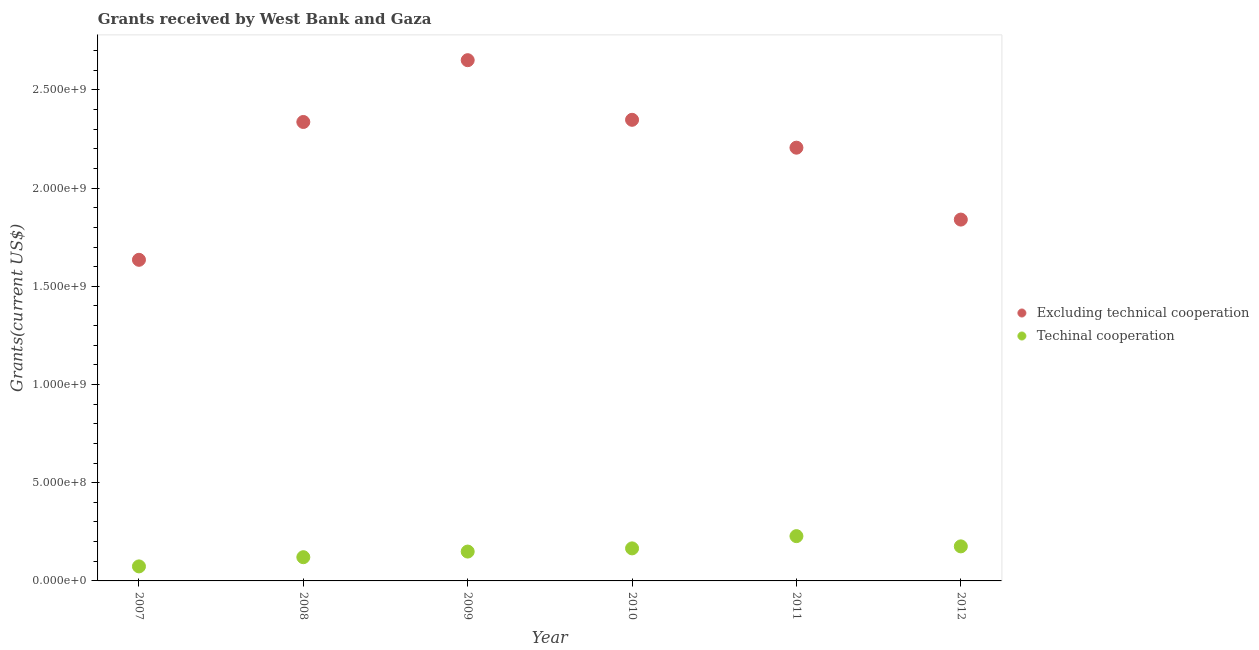How many different coloured dotlines are there?
Your response must be concise. 2. Is the number of dotlines equal to the number of legend labels?
Offer a terse response. Yes. What is the amount of grants received(including technical cooperation) in 2009?
Your answer should be compact. 1.49e+08. Across all years, what is the maximum amount of grants received(excluding technical cooperation)?
Ensure brevity in your answer.  2.65e+09. Across all years, what is the minimum amount of grants received(including technical cooperation)?
Your answer should be compact. 7.39e+07. What is the total amount of grants received(including technical cooperation) in the graph?
Your response must be concise. 9.14e+08. What is the difference between the amount of grants received(including technical cooperation) in 2009 and that in 2012?
Make the answer very short. -2.64e+07. What is the difference between the amount of grants received(including technical cooperation) in 2011 and the amount of grants received(excluding technical cooperation) in 2007?
Your answer should be compact. -1.41e+09. What is the average amount of grants received(including technical cooperation) per year?
Keep it short and to the point. 1.52e+08. In the year 2007, what is the difference between the amount of grants received(excluding technical cooperation) and amount of grants received(including technical cooperation)?
Give a very brief answer. 1.56e+09. In how many years, is the amount of grants received(including technical cooperation) greater than 400000000 US$?
Ensure brevity in your answer.  0. What is the ratio of the amount of grants received(including technical cooperation) in 2008 to that in 2009?
Your answer should be compact. 0.81. Is the difference between the amount of grants received(including technical cooperation) in 2007 and 2009 greater than the difference between the amount of grants received(excluding technical cooperation) in 2007 and 2009?
Keep it short and to the point. Yes. What is the difference between the highest and the second highest amount of grants received(excluding technical cooperation)?
Offer a very short reply. 3.04e+08. What is the difference between the highest and the lowest amount of grants received(including technical cooperation)?
Ensure brevity in your answer.  1.54e+08. In how many years, is the amount of grants received(excluding technical cooperation) greater than the average amount of grants received(excluding technical cooperation) taken over all years?
Provide a succinct answer. 4. Is the sum of the amount of grants received(excluding technical cooperation) in 2007 and 2012 greater than the maximum amount of grants received(including technical cooperation) across all years?
Offer a terse response. Yes. Is the amount of grants received(including technical cooperation) strictly less than the amount of grants received(excluding technical cooperation) over the years?
Ensure brevity in your answer.  Yes. How many dotlines are there?
Make the answer very short. 2. How many years are there in the graph?
Make the answer very short. 6. Does the graph contain any zero values?
Keep it short and to the point. No. Does the graph contain grids?
Your answer should be compact. No. Where does the legend appear in the graph?
Offer a very short reply. Center right. How are the legend labels stacked?
Keep it short and to the point. Vertical. What is the title of the graph?
Keep it short and to the point. Grants received by West Bank and Gaza. Does "Investment in Telecom" appear as one of the legend labels in the graph?
Give a very brief answer. No. What is the label or title of the Y-axis?
Your answer should be compact. Grants(current US$). What is the Grants(current US$) of Excluding technical cooperation in 2007?
Your answer should be very brief. 1.63e+09. What is the Grants(current US$) in Techinal cooperation in 2007?
Make the answer very short. 7.39e+07. What is the Grants(current US$) of Excluding technical cooperation in 2008?
Offer a very short reply. 2.34e+09. What is the Grants(current US$) in Techinal cooperation in 2008?
Your answer should be very brief. 1.21e+08. What is the Grants(current US$) in Excluding technical cooperation in 2009?
Make the answer very short. 2.65e+09. What is the Grants(current US$) of Techinal cooperation in 2009?
Offer a very short reply. 1.49e+08. What is the Grants(current US$) of Excluding technical cooperation in 2010?
Provide a succinct answer. 2.35e+09. What is the Grants(current US$) in Techinal cooperation in 2010?
Give a very brief answer. 1.66e+08. What is the Grants(current US$) in Excluding technical cooperation in 2011?
Make the answer very short. 2.21e+09. What is the Grants(current US$) of Techinal cooperation in 2011?
Provide a succinct answer. 2.28e+08. What is the Grants(current US$) of Excluding technical cooperation in 2012?
Give a very brief answer. 1.84e+09. What is the Grants(current US$) in Techinal cooperation in 2012?
Your answer should be very brief. 1.76e+08. Across all years, what is the maximum Grants(current US$) in Excluding technical cooperation?
Offer a very short reply. 2.65e+09. Across all years, what is the maximum Grants(current US$) of Techinal cooperation?
Provide a succinct answer. 2.28e+08. Across all years, what is the minimum Grants(current US$) in Excluding technical cooperation?
Your response must be concise. 1.63e+09. Across all years, what is the minimum Grants(current US$) of Techinal cooperation?
Offer a very short reply. 7.39e+07. What is the total Grants(current US$) of Excluding technical cooperation in the graph?
Offer a very short reply. 1.30e+1. What is the total Grants(current US$) of Techinal cooperation in the graph?
Your answer should be compact. 9.14e+08. What is the difference between the Grants(current US$) in Excluding technical cooperation in 2007 and that in 2008?
Provide a short and direct response. -7.02e+08. What is the difference between the Grants(current US$) of Techinal cooperation in 2007 and that in 2008?
Offer a very short reply. -4.69e+07. What is the difference between the Grants(current US$) of Excluding technical cooperation in 2007 and that in 2009?
Your response must be concise. -1.02e+09. What is the difference between the Grants(current US$) in Techinal cooperation in 2007 and that in 2009?
Keep it short and to the point. -7.55e+07. What is the difference between the Grants(current US$) of Excluding technical cooperation in 2007 and that in 2010?
Offer a very short reply. -7.13e+08. What is the difference between the Grants(current US$) of Techinal cooperation in 2007 and that in 2010?
Give a very brief answer. -9.18e+07. What is the difference between the Grants(current US$) of Excluding technical cooperation in 2007 and that in 2011?
Ensure brevity in your answer.  -5.71e+08. What is the difference between the Grants(current US$) of Techinal cooperation in 2007 and that in 2011?
Offer a terse response. -1.54e+08. What is the difference between the Grants(current US$) in Excluding technical cooperation in 2007 and that in 2012?
Give a very brief answer. -2.05e+08. What is the difference between the Grants(current US$) of Techinal cooperation in 2007 and that in 2012?
Offer a terse response. -1.02e+08. What is the difference between the Grants(current US$) in Excluding technical cooperation in 2008 and that in 2009?
Your answer should be very brief. -3.15e+08. What is the difference between the Grants(current US$) of Techinal cooperation in 2008 and that in 2009?
Give a very brief answer. -2.86e+07. What is the difference between the Grants(current US$) in Excluding technical cooperation in 2008 and that in 2010?
Offer a very short reply. -1.10e+07. What is the difference between the Grants(current US$) in Techinal cooperation in 2008 and that in 2010?
Offer a very short reply. -4.49e+07. What is the difference between the Grants(current US$) of Excluding technical cooperation in 2008 and that in 2011?
Your answer should be very brief. 1.31e+08. What is the difference between the Grants(current US$) of Techinal cooperation in 2008 and that in 2011?
Offer a terse response. -1.07e+08. What is the difference between the Grants(current US$) in Excluding technical cooperation in 2008 and that in 2012?
Offer a very short reply. 4.97e+08. What is the difference between the Grants(current US$) in Techinal cooperation in 2008 and that in 2012?
Provide a succinct answer. -5.51e+07. What is the difference between the Grants(current US$) of Excluding technical cooperation in 2009 and that in 2010?
Make the answer very short. 3.04e+08. What is the difference between the Grants(current US$) of Techinal cooperation in 2009 and that in 2010?
Your answer should be compact. -1.62e+07. What is the difference between the Grants(current US$) in Excluding technical cooperation in 2009 and that in 2011?
Your answer should be compact. 4.45e+08. What is the difference between the Grants(current US$) of Techinal cooperation in 2009 and that in 2011?
Ensure brevity in your answer.  -7.86e+07. What is the difference between the Grants(current US$) in Excluding technical cooperation in 2009 and that in 2012?
Provide a succinct answer. 8.11e+08. What is the difference between the Grants(current US$) in Techinal cooperation in 2009 and that in 2012?
Give a very brief answer. -2.64e+07. What is the difference between the Grants(current US$) of Excluding technical cooperation in 2010 and that in 2011?
Provide a succinct answer. 1.42e+08. What is the difference between the Grants(current US$) in Techinal cooperation in 2010 and that in 2011?
Your answer should be compact. -6.23e+07. What is the difference between the Grants(current US$) of Excluding technical cooperation in 2010 and that in 2012?
Your answer should be compact. 5.08e+08. What is the difference between the Grants(current US$) of Techinal cooperation in 2010 and that in 2012?
Your answer should be very brief. -1.02e+07. What is the difference between the Grants(current US$) in Excluding technical cooperation in 2011 and that in 2012?
Make the answer very short. 3.66e+08. What is the difference between the Grants(current US$) in Techinal cooperation in 2011 and that in 2012?
Offer a very short reply. 5.21e+07. What is the difference between the Grants(current US$) in Excluding technical cooperation in 2007 and the Grants(current US$) in Techinal cooperation in 2008?
Keep it short and to the point. 1.51e+09. What is the difference between the Grants(current US$) of Excluding technical cooperation in 2007 and the Grants(current US$) of Techinal cooperation in 2009?
Make the answer very short. 1.49e+09. What is the difference between the Grants(current US$) in Excluding technical cooperation in 2007 and the Grants(current US$) in Techinal cooperation in 2010?
Your answer should be very brief. 1.47e+09. What is the difference between the Grants(current US$) of Excluding technical cooperation in 2007 and the Grants(current US$) of Techinal cooperation in 2011?
Offer a terse response. 1.41e+09. What is the difference between the Grants(current US$) in Excluding technical cooperation in 2007 and the Grants(current US$) in Techinal cooperation in 2012?
Ensure brevity in your answer.  1.46e+09. What is the difference between the Grants(current US$) of Excluding technical cooperation in 2008 and the Grants(current US$) of Techinal cooperation in 2009?
Offer a very short reply. 2.19e+09. What is the difference between the Grants(current US$) in Excluding technical cooperation in 2008 and the Grants(current US$) in Techinal cooperation in 2010?
Your answer should be very brief. 2.17e+09. What is the difference between the Grants(current US$) in Excluding technical cooperation in 2008 and the Grants(current US$) in Techinal cooperation in 2011?
Your response must be concise. 2.11e+09. What is the difference between the Grants(current US$) of Excluding technical cooperation in 2008 and the Grants(current US$) of Techinal cooperation in 2012?
Provide a succinct answer. 2.16e+09. What is the difference between the Grants(current US$) of Excluding technical cooperation in 2009 and the Grants(current US$) of Techinal cooperation in 2010?
Provide a succinct answer. 2.49e+09. What is the difference between the Grants(current US$) of Excluding technical cooperation in 2009 and the Grants(current US$) of Techinal cooperation in 2011?
Your response must be concise. 2.42e+09. What is the difference between the Grants(current US$) in Excluding technical cooperation in 2009 and the Grants(current US$) in Techinal cooperation in 2012?
Your answer should be compact. 2.48e+09. What is the difference between the Grants(current US$) in Excluding technical cooperation in 2010 and the Grants(current US$) in Techinal cooperation in 2011?
Ensure brevity in your answer.  2.12e+09. What is the difference between the Grants(current US$) in Excluding technical cooperation in 2010 and the Grants(current US$) in Techinal cooperation in 2012?
Give a very brief answer. 2.17e+09. What is the difference between the Grants(current US$) in Excluding technical cooperation in 2011 and the Grants(current US$) in Techinal cooperation in 2012?
Keep it short and to the point. 2.03e+09. What is the average Grants(current US$) of Excluding technical cooperation per year?
Your answer should be compact. 2.17e+09. What is the average Grants(current US$) in Techinal cooperation per year?
Keep it short and to the point. 1.52e+08. In the year 2007, what is the difference between the Grants(current US$) of Excluding technical cooperation and Grants(current US$) of Techinal cooperation?
Keep it short and to the point. 1.56e+09. In the year 2008, what is the difference between the Grants(current US$) of Excluding technical cooperation and Grants(current US$) of Techinal cooperation?
Ensure brevity in your answer.  2.22e+09. In the year 2009, what is the difference between the Grants(current US$) of Excluding technical cooperation and Grants(current US$) of Techinal cooperation?
Offer a terse response. 2.50e+09. In the year 2010, what is the difference between the Grants(current US$) of Excluding technical cooperation and Grants(current US$) of Techinal cooperation?
Your response must be concise. 2.18e+09. In the year 2011, what is the difference between the Grants(current US$) of Excluding technical cooperation and Grants(current US$) of Techinal cooperation?
Provide a short and direct response. 1.98e+09. In the year 2012, what is the difference between the Grants(current US$) of Excluding technical cooperation and Grants(current US$) of Techinal cooperation?
Keep it short and to the point. 1.66e+09. What is the ratio of the Grants(current US$) of Excluding technical cooperation in 2007 to that in 2008?
Provide a succinct answer. 0.7. What is the ratio of the Grants(current US$) of Techinal cooperation in 2007 to that in 2008?
Your answer should be compact. 0.61. What is the ratio of the Grants(current US$) in Excluding technical cooperation in 2007 to that in 2009?
Your answer should be compact. 0.62. What is the ratio of the Grants(current US$) of Techinal cooperation in 2007 to that in 2009?
Offer a terse response. 0.49. What is the ratio of the Grants(current US$) of Excluding technical cooperation in 2007 to that in 2010?
Give a very brief answer. 0.7. What is the ratio of the Grants(current US$) of Techinal cooperation in 2007 to that in 2010?
Your answer should be compact. 0.45. What is the ratio of the Grants(current US$) of Excluding technical cooperation in 2007 to that in 2011?
Offer a very short reply. 0.74. What is the ratio of the Grants(current US$) of Techinal cooperation in 2007 to that in 2011?
Ensure brevity in your answer.  0.32. What is the ratio of the Grants(current US$) in Excluding technical cooperation in 2007 to that in 2012?
Provide a short and direct response. 0.89. What is the ratio of the Grants(current US$) of Techinal cooperation in 2007 to that in 2012?
Offer a terse response. 0.42. What is the ratio of the Grants(current US$) in Excluding technical cooperation in 2008 to that in 2009?
Ensure brevity in your answer.  0.88. What is the ratio of the Grants(current US$) in Techinal cooperation in 2008 to that in 2009?
Offer a terse response. 0.81. What is the ratio of the Grants(current US$) of Excluding technical cooperation in 2008 to that in 2010?
Your answer should be compact. 1. What is the ratio of the Grants(current US$) of Techinal cooperation in 2008 to that in 2010?
Keep it short and to the point. 0.73. What is the ratio of the Grants(current US$) in Excluding technical cooperation in 2008 to that in 2011?
Your answer should be very brief. 1.06. What is the ratio of the Grants(current US$) of Techinal cooperation in 2008 to that in 2011?
Your answer should be compact. 0.53. What is the ratio of the Grants(current US$) of Excluding technical cooperation in 2008 to that in 2012?
Ensure brevity in your answer.  1.27. What is the ratio of the Grants(current US$) of Techinal cooperation in 2008 to that in 2012?
Keep it short and to the point. 0.69. What is the ratio of the Grants(current US$) in Excluding technical cooperation in 2009 to that in 2010?
Make the answer very short. 1.13. What is the ratio of the Grants(current US$) of Techinal cooperation in 2009 to that in 2010?
Your response must be concise. 0.9. What is the ratio of the Grants(current US$) of Excluding technical cooperation in 2009 to that in 2011?
Your response must be concise. 1.2. What is the ratio of the Grants(current US$) of Techinal cooperation in 2009 to that in 2011?
Ensure brevity in your answer.  0.66. What is the ratio of the Grants(current US$) in Excluding technical cooperation in 2009 to that in 2012?
Your response must be concise. 1.44. What is the ratio of the Grants(current US$) of Techinal cooperation in 2009 to that in 2012?
Your response must be concise. 0.85. What is the ratio of the Grants(current US$) in Excluding technical cooperation in 2010 to that in 2011?
Your response must be concise. 1.06. What is the ratio of the Grants(current US$) of Techinal cooperation in 2010 to that in 2011?
Provide a succinct answer. 0.73. What is the ratio of the Grants(current US$) in Excluding technical cooperation in 2010 to that in 2012?
Offer a very short reply. 1.28. What is the ratio of the Grants(current US$) in Techinal cooperation in 2010 to that in 2012?
Ensure brevity in your answer.  0.94. What is the ratio of the Grants(current US$) in Excluding technical cooperation in 2011 to that in 2012?
Your answer should be compact. 1.2. What is the ratio of the Grants(current US$) of Techinal cooperation in 2011 to that in 2012?
Ensure brevity in your answer.  1.3. What is the difference between the highest and the second highest Grants(current US$) of Excluding technical cooperation?
Your response must be concise. 3.04e+08. What is the difference between the highest and the second highest Grants(current US$) of Techinal cooperation?
Your answer should be very brief. 5.21e+07. What is the difference between the highest and the lowest Grants(current US$) in Excluding technical cooperation?
Provide a succinct answer. 1.02e+09. What is the difference between the highest and the lowest Grants(current US$) of Techinal cooperation?
Provide a succinct answer. 1.54e+08. 